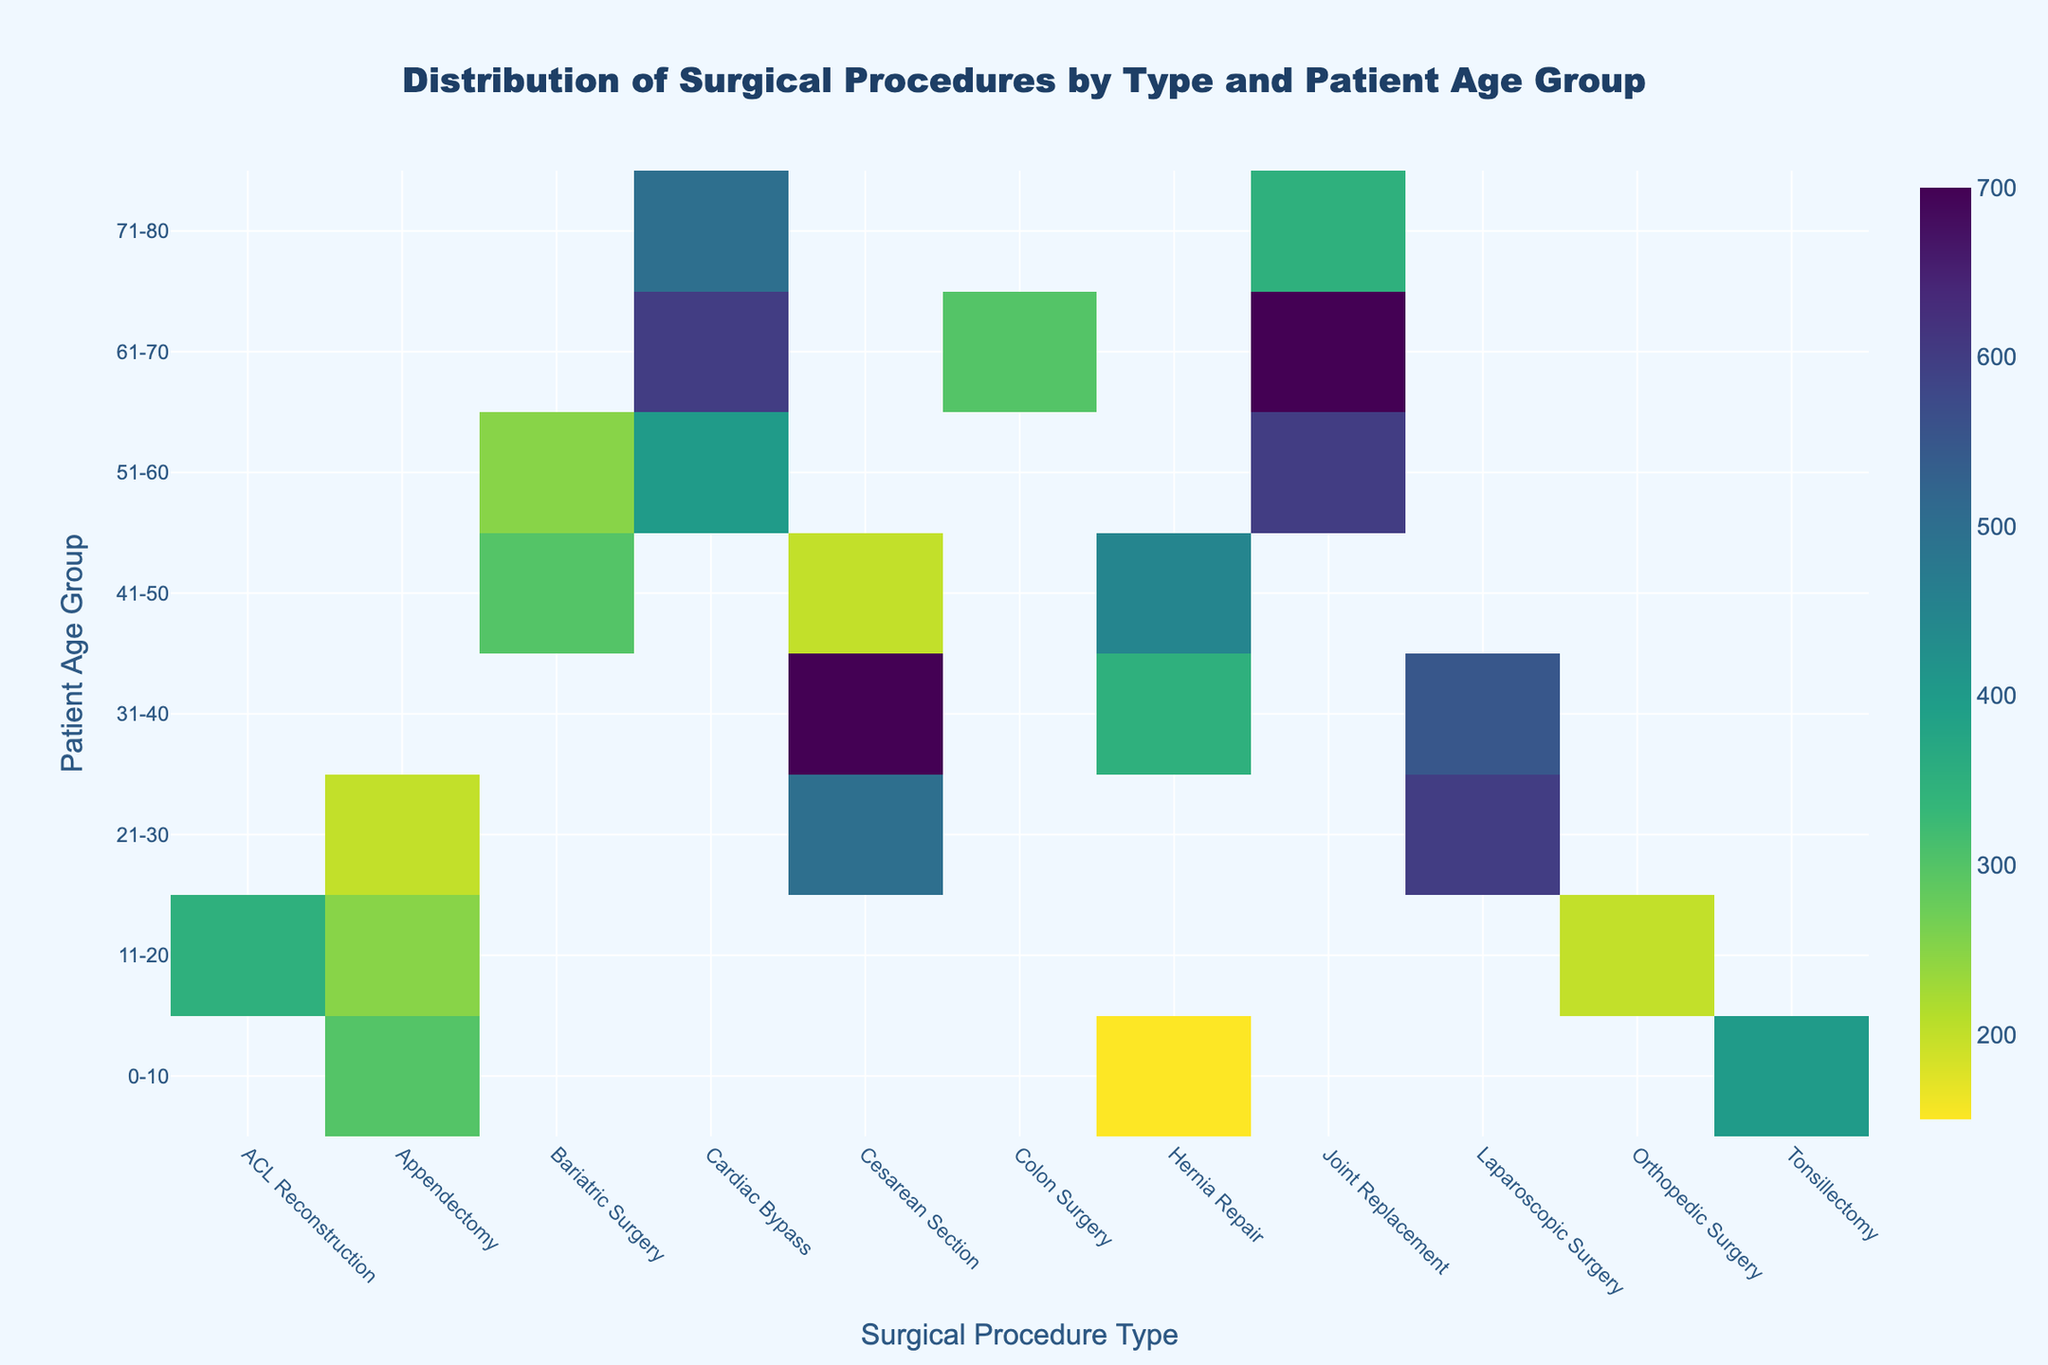What is the title of the heatmap? The title of the heatmap is prominently displayed at the top center of the figure.
Answer: Distribution of Surgical Procedures by Type and Patient Age Group Which patient age group has the highest number of Appendectomy procedures? Look for the cell corresponding to 'Appendectomy' in each age group row and identify the highest value.
Answer: 0-10 How many Cesarean Sections were performed on patients aged 31-40? Locate the cell where the '31-40' row intersects with the 'Cesarean Section' column.
Answer: 700 What is the total number of Hernia Repair procedures across all age groups? Sum the values in the 'Hernia Repair' column across all age group rows. 150 (0-10) + 350 (31-40) + 450 (41-50) = 950.
Answer: 950 Which surgical procedure type is most common for patients aged 21-30? Identify the cell in the '21-30' row with the highest value.
Answer: Laparoscopic Surgery Compare the number of Joint Replacement procedures between patients aged 51-60 and those aged 61-70. Locate the cells for 'Joint Replacement' in the '51-60' and '61-70' rows and compare the values.
Answer: 700 (61-70) is greater than 600 (51-60) Is there any patient age group that did not undergo Cardiac Bypass surgery? Check each row to see if there are any null or missing values in the 'Cardiac Bypass' column.
Answer: 0-10, 11-20, 21-30, 31-40 What's the average number of procedures for Appendectomy across all age groups? Add up all values in the 'Appendectomy' column and divide by the number of age groups where the procedure is listed: 300 (0-10) + 250 (11-20) + 200 (21-30) = 750; 750 / 3 = 250.
Answer: 250 What age group has the least number of Tonsillectomy procedures and how many were performed? Locate the 'Tonsillectomy' column and identify the row with the minimum value.
Answer: 0-10, 400 What's the difference in the number of Cesarean Sections performed between the 31-40 and 41-50 age groups? Subtract the number of procedures in the '41-50' age group from the number in the '31-40' age group: 700 (31-40) - 200 (41-50) = 500.
Answer: 500 